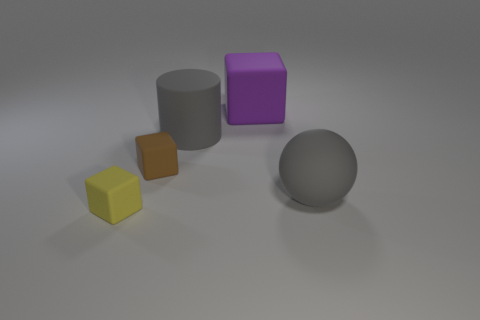Subtract all big rubber blocks. How many blocks are left? 2 Subtract all purple blocks. How many blocks are left? 2 Subtract all cubes. How many objects are left? 2 Subtract 1 spheres. How many spheres are left? 0 Add 1 small objects. How many objects exist? 6 Subtract all rubber things. Subtract all small red matte cylinders. How many objects are left? 0 Add 5 gray rubber cylinders. How many gray rubber cylinders are left? 6 Add 1 small red rubber cylinders. How many small red rubber cylinders exist? 1 Subtract 0 purple balls. How many objects are left? 5 Subtract all brown cylinders. Subtract all red blocks. How many cylinders are left? 1 